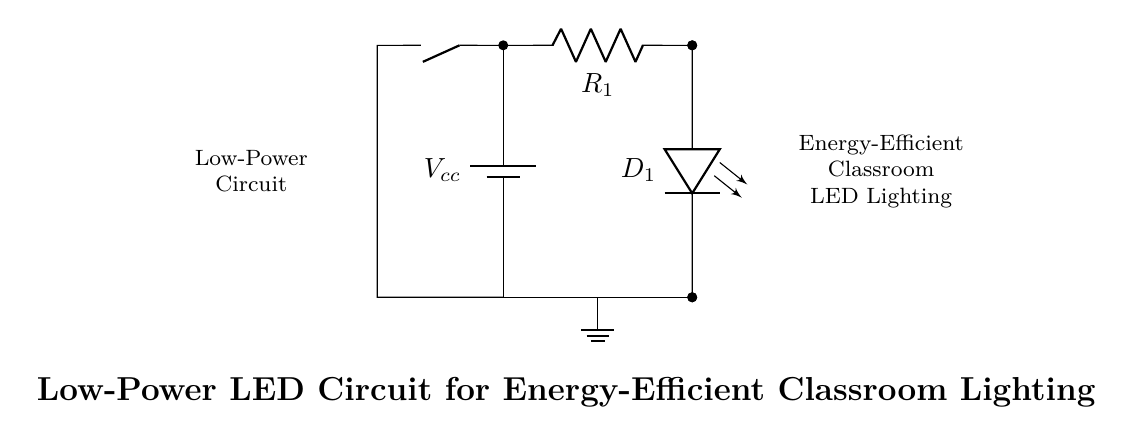What is the type of power supply used in the circuit? The circuit uses a battery as indicated by the symbol and the label Vcc, which signifies the voltage supply.
Answer: battery What component limits the current in this circuit? The resistor labeled R1 is responsible for limiting the current flowing through the LED, preventing it from drawing too much current and potentially burning out.
Answer: R1 What is the function of the switch in this circuit? The switch allows the circuit to be opened or closed, controlling whether the LED is on or off by breaking or making the connection to the power supply.
Answer: to control the LED Which component indicates the direction of current flow? The LED, labeled D1, shows the direction of current flow because it only allows current to pass through in one direction indicated by its orientation.
Answer: D1 How many components are connected in series in this circuit? There are three components connected in series: the battery, the resistor R1, and the LED D1. Each component shares the same current and is arranged end-to-end.
Answer: three components What is the purpose of using a low-power LED in this circuit? The primary purpose of using a low-power LED is to enhance energy efficiency in classroom lighting, allowing for reduced energy consumption and lower operating costs.
Answer: energy efficiency What does the ground symbol represent in this diagram? The ground symbol represents a common return path for the electric current, ensuring that all components of the circuit have a reference point for zero voltage.
Answer: common return 